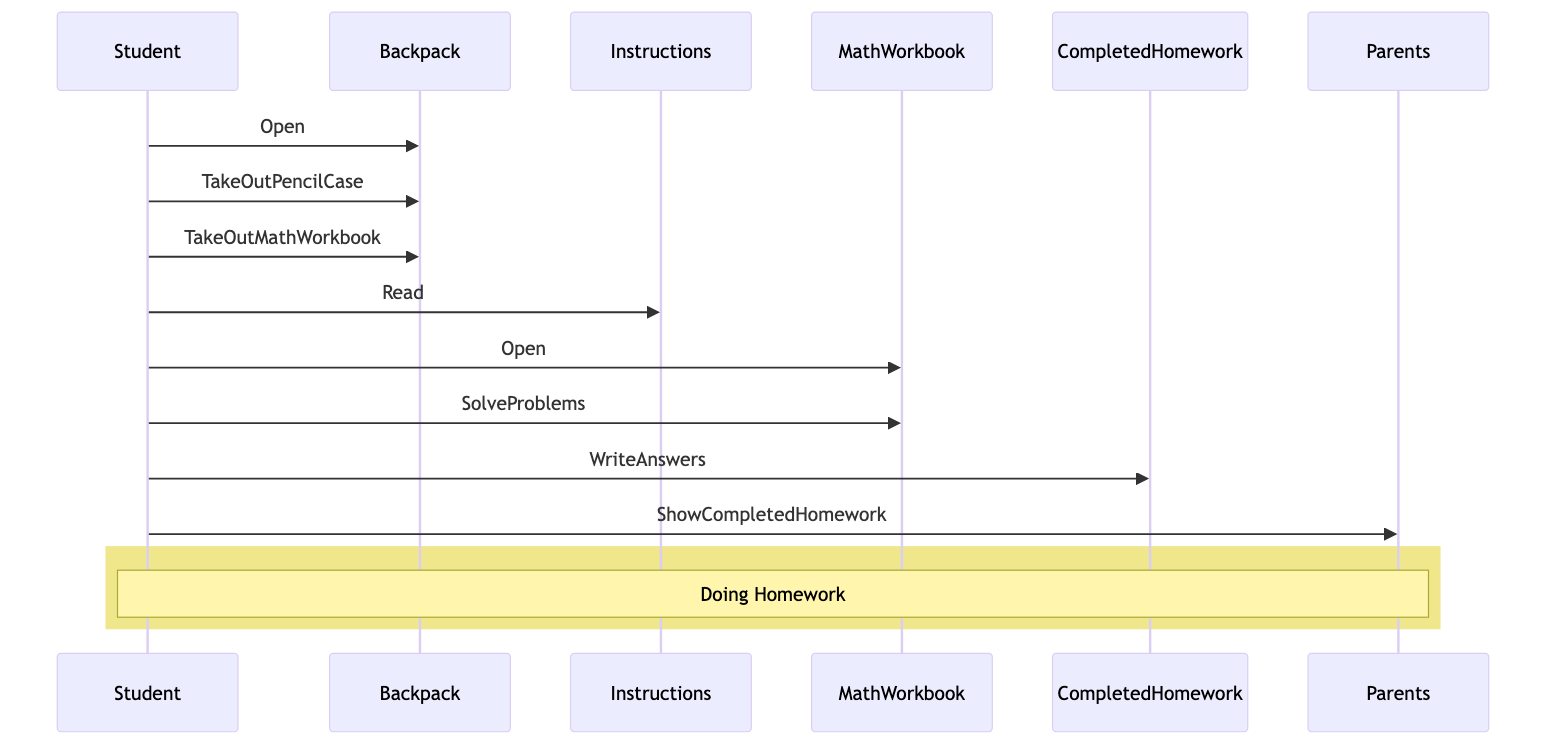What is the first action the Student does? The first action listed in the sequence is "Open," which is directed from the Student to the Backpack. This shows that the Student opens the Backpack first.
Answer: Open How many objects are involved in this diagram? The diagram includes five objects: Backpack, Instructions, MathWorkbook, CompletedHomework, and Parents. So, counting these gives a total of five objects.
Answer: 5 Who does the Student show the Completed Homework to? The Student shows the Completed Homework to the Parents, as indicated by the action "ShowCompletedHomework" directed to Parents at the end of the sequence.
Answer: Parents What action follows after the Student reads the Instructions? The action that follows after "Read" is "Open" directed from the Student to the MathWorkbook. This indicates that after reading, the Student proceeds to open the MathWorkbook.
Answer: Open What type of diagram is this? This is a sequence diagram, which depicts the order of actions performed by the Student in the process of doing homework.
Answer: Sequence diagram What does the Student take out of the Backpack? The Student takes out a Pencil Case and a Math Workbook from the Backpack, as indicated by the actions "TakeOutPencilCase" and "TakeOutMathWorkbook."
Answer: Pencil Case and Math Workbook How many actions does the Student perform? The Student performs seven actions in the sequence: Open, TakeOutPencilCase, TakeOutMathWorkbook, Read, Open, SolveProblems, and WriteAnswers. Counting these actions results in seven.
Answer: 7 What is written by the Student? The Student writes "Answers" in the Completed Homework, as specified in the action "WriteAnswers." This indicates that the Student is focusing on completing the homework.
Answer: Answers 